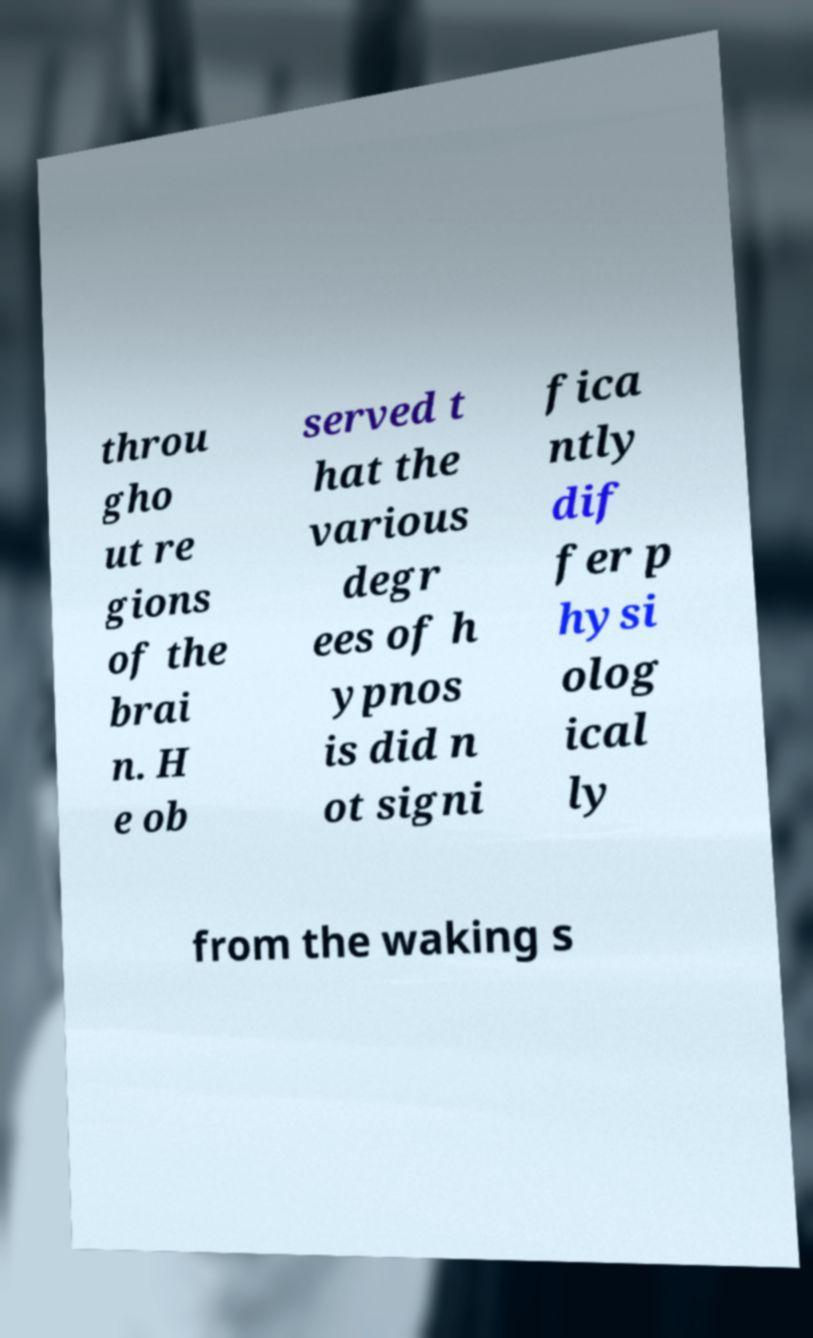Please read and relay the text visible in this image. What does it say? throu gho ut re gions of the brai n. H e ob served t hat the various degr ees of h ypnos is did n ot signi fica ntly dif fer p hysi olog ical ly from the waking s 